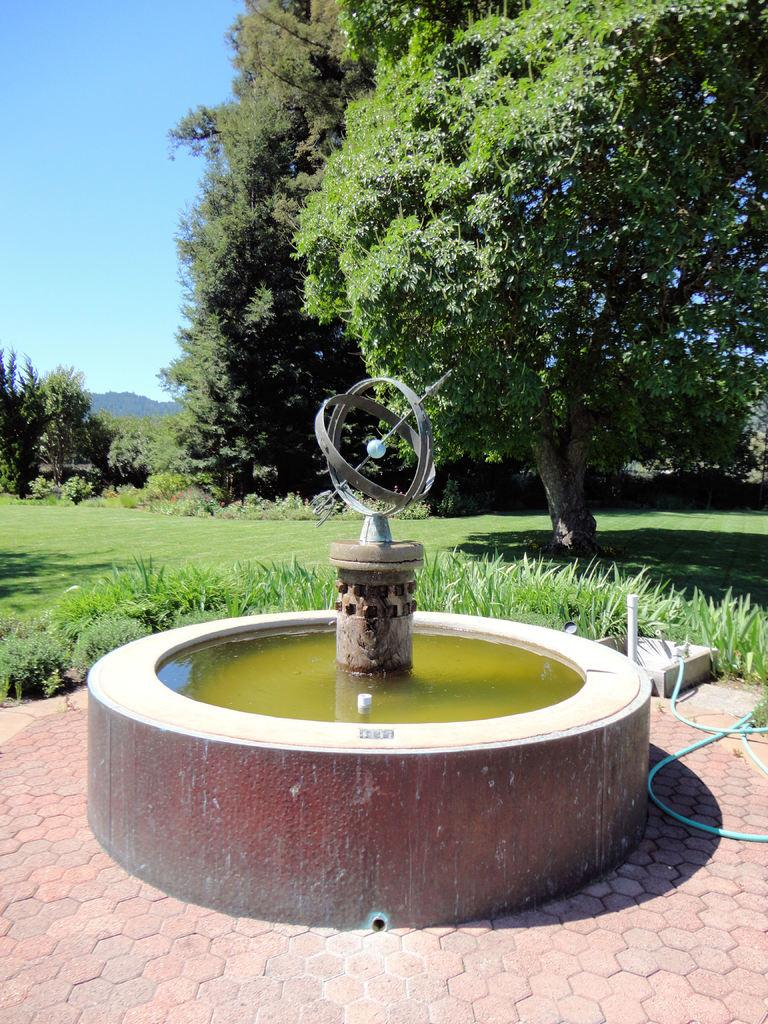What is the main feature in the image? There is a fountain in the image. What is connected to the fountain? There is a pipe in the image. What is flowing through the pipe? Water is visible in the image. What type of vegetation is present in the image? There are trees and grass in the image. What can be seen in the background of the image? The sky is visible in the background of the image. What type of cart is being pulled by the dog in the image? There is no cart or dog present in the image. 